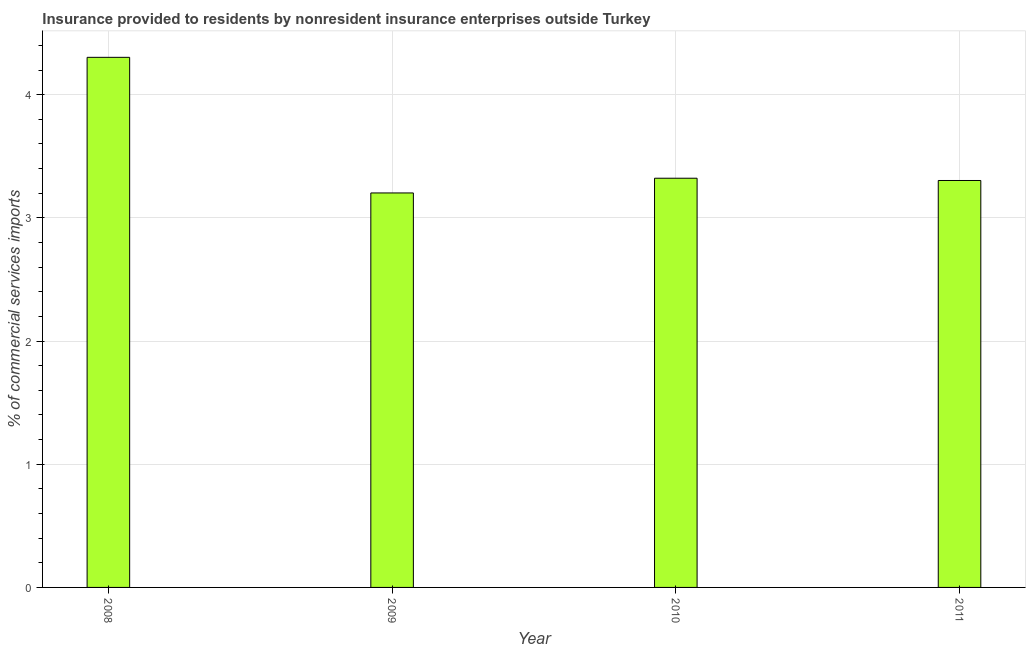What is the title of the graph?
Ensure brevity in your answer.  Insurance provided to residents by nonresident insurance enterprises outside Turkey. What is the label or title of the Y-axis?
Keep it short and to the point. % of commercial services imports. What is the insurance provided by non-residents in 2008?
Make the answer very short. 4.3. Across all years, what is the maximum insurance provided by non-residents?
Your answer should be compact. 4.3. Across all years, what is the minimum insurance provided by non-residents?
Offer a terse response. 3.2. What is the sum of the insurance provided by non-residents?
Make the answer very short. 14.13. What is the difference between the insurance provided by non-residents in 2010 and 2011?
Ensure brevity in your answer.  0.02. What is the average insurance provided by non-residents per year?
Provide a succinct answer. 3.53. What is the median insurance provided by non-residents?
Offer a very short reply. 3.31. In how many years, is the insurance provided by non-residents greater than 2.6 %?
Provide a short and direct response. 4. Do a majority of the years between 2009 and 2010 (inclusive) have insurance provided by non-residents greater than 2.4 %?
Keep it short and to the point. Yes. Is the insurance provided by non-residents in 2009 less than that in 2011?
Your response must be concise. Yes. What is the difference between the highest and the second highest insurance provided by non-residents?
Make the answer very short. 0.98. In how many years, is the insurance provided by non-residents greater than the average insurance provided by non-residents taken over all years?
Offer a very short reply. 1. Are all the bars in the graph horizontal?
Ensure brevity in your answer.  No. How many years are there in the graph?
Provide a short and direct response. 4. Are the values on the major ticks of Y-axis written in scientific E-notation?
Provide a succinct answer. No. What is the % of commercial services imports in 2008?
Ensure brevity in your answer.  4.3. What is the % of commercial services imports of 2009?
Offer a terse response. 3.2. What is the % of commercial services imports of 2010?
Your response must be concise. 3.32. What is the % of commercial services imports of 2011?
Offer a terse response. 3.3. What is the difference between the % of commercial services imports in 2008 and 2009?
Your answer should be compact. 1.1. What is the difference between the % of commercial services imports in 2008 and 2010?
Provide a succinct answer. 0.98. What is the difference between the % of commercial services imports in 2008 and 2011?
Provide a succinct answer. 1. What is the difference between the % of commercial services imports in 2009 and 2010?
Your answer should be compact. -0.12. What is the difference between the % of commercial services imports in 2009 and 2011?
Provide a succinct answer. -0.1. What is the difference between the % of commercial services imports in 2010 and 2011?
Offer a very short reply. 0.02. What is the ratio of the % of commercial services imports in 2008 to that in 2009?
Make the answer very short. 1.34. What is the ratio of the % of commercial services imports in 2008 to that in 2010?
Offer a very short reply. 1.29. What is the ratio of the % of commercial services imports in 2008 to that in 2011?
Keep it short and to the point. 1.3. What is the ratio of the % of commercial services imports in 2009 to that in 2011?
Your answer should be compact. 0.97. What is the ratio of the % of commercial services imports in 2010 to that in 2011?
Your answer should be compact. 1.01. 